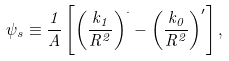Convert formula to latex. <formula><loc_0><loc_0><loc_500><loc_500>\psi _ { s } \equiv \frac { 1 } { A } \left [ { \left ( \frac { k _ { 1 } } { R ^ { 2 } } \right ) ^ { \cdot } } - \left ( \frac { k _ { 0 } } { R ^ { 2 } } \right ) ^ { \prime } \right ] ,</formula> 